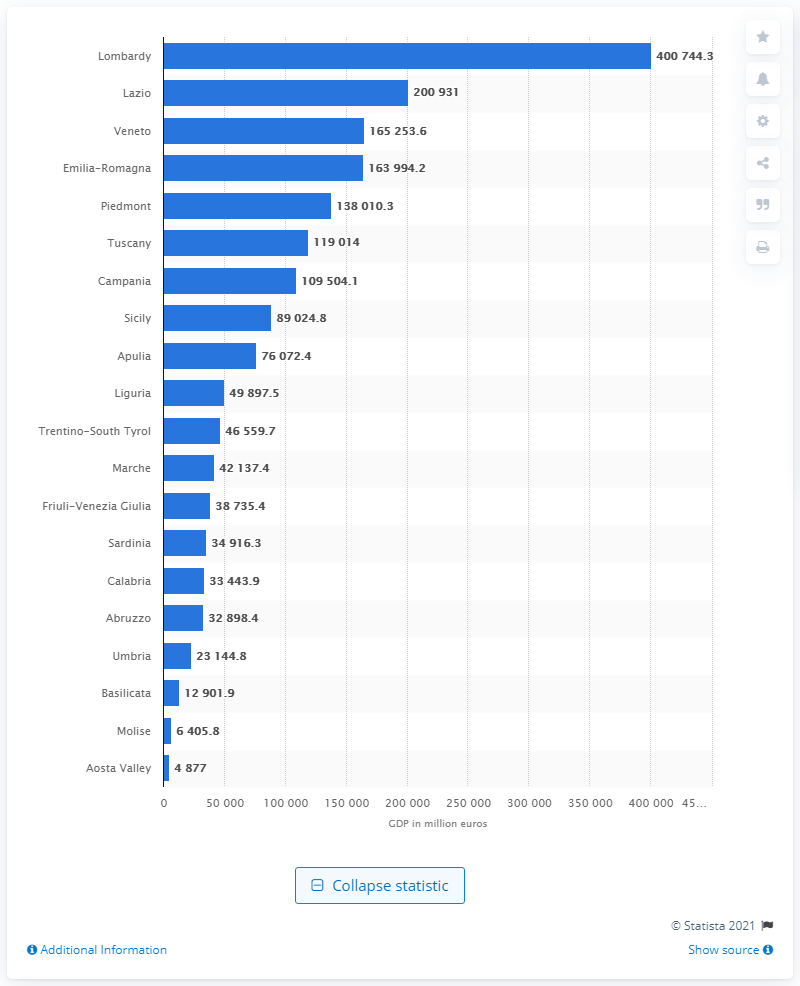Give some essential details in this illustration. In 2019, Lazio region had the highest gross domestic product among all regions in Italy. The lowest GDP in Italy was recorded in the Aosta Valley. The lowest GDP was recorded in the region of Molise in the South of Italy. The Gross Domestic Product in Lombardy in 2019 was 400,744.3. 